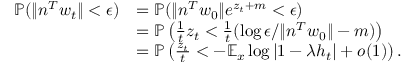Convert formula to latex. <formula><loc_0><loc_0><loc_500><loc_500>\begin{array} { r l } { \mathbb { P } ( \| n ^ { T } w _ { t } \| < \epsilon ) } & { = \mathbb { P } ( \| n ^ { T } w _ { 0 } \| e ^ { z _ { t } + m } < \epsilon ) } \\ & { = \mathbb { P } \left ( \frac { 1 } { t } z _ { t } < \frac { 1 } { t } ( \log \epsilon / \| n ^ { T } w _ { 0 } \| - m ) \right ) } \\ & { = \mathbb { P } \left ( \frac { z _ { t } } { t } < - \mathbb { E } _ { x } \log | 1 - \lambda h _ { t } | + o ( 1 ) \right ) . } \end{array}</formula> 